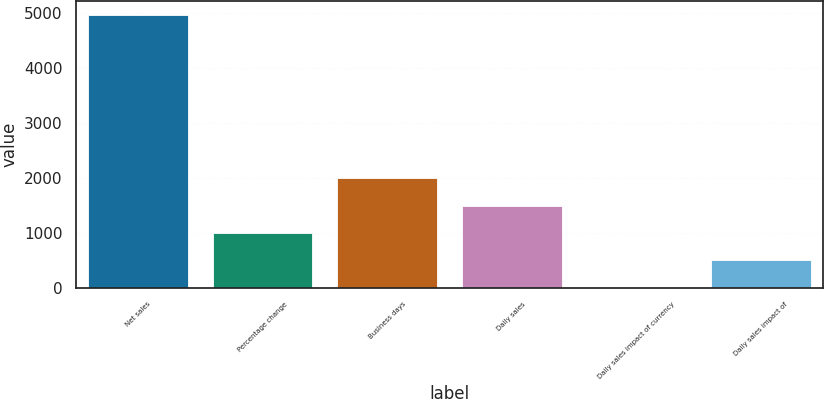<chart> <loc_0><loc_0><loc_500><loc_500><bar_chart><fcel>Net sales<fcel>Percentage change<fcel>Business days<fcel>Daily sales<fcel>Daily sales impact of currency<fcel>Daily sales impact of<nl><fcel>4965.1<fcel>993.1<fcel>1986.1<fcel>1489.6<fcel>0.1<fcel>496.6<nl></chart> 